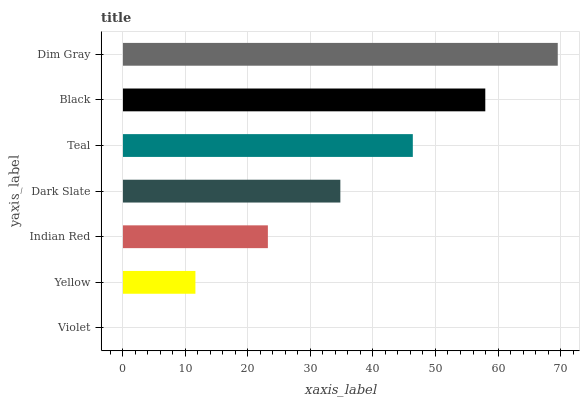Is Violet the minimum?
Answer yes or no. Yes. Is Dim Gray the maximum?
Answer yes or no. Yes. Is Yellow the minimum?
Answer yes or no. No. Is Yellow the maximum?
Answer yes or no. No. Is Yellow greater than Violet?
Answer yes or no. Yes. Is Violet less than Yellow?
Answer yes or no. Yes. Is Violet greater than Yellow?
Answer yes or no. No. Is Yellow less than Violet?
Answer yes or no. No. Is Dark Slate the high median?
Answer yes or no. Yes. Is Dark Slate the low median?
Answer yes or no. Yes. Is Violet the high median?
Answer yes or no. No. Is Black the low median?
Answer yes or no. No. 